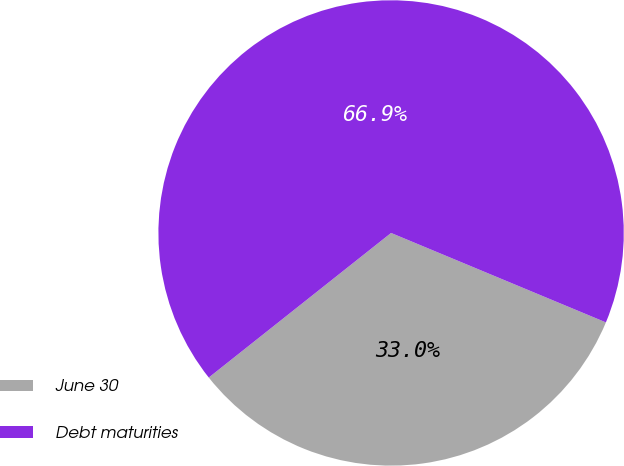<chart> <loc_0><loc_0><loc_500><loc_500><pie_chart><fcel>June 30<fcel>Debt maturities<nl><fcel>33.05%<fcel>66.95%<nl></chart> 